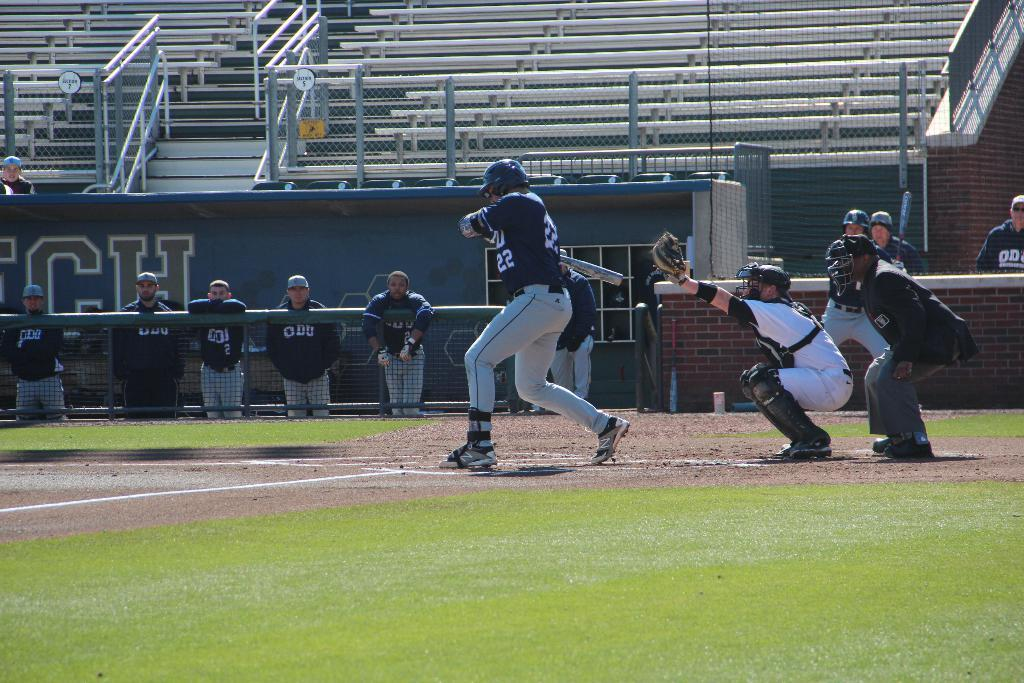<image>
Give a short and clear explanation of the subsequent image. A baseball player has the number 22 on his shirt and is at bat. 